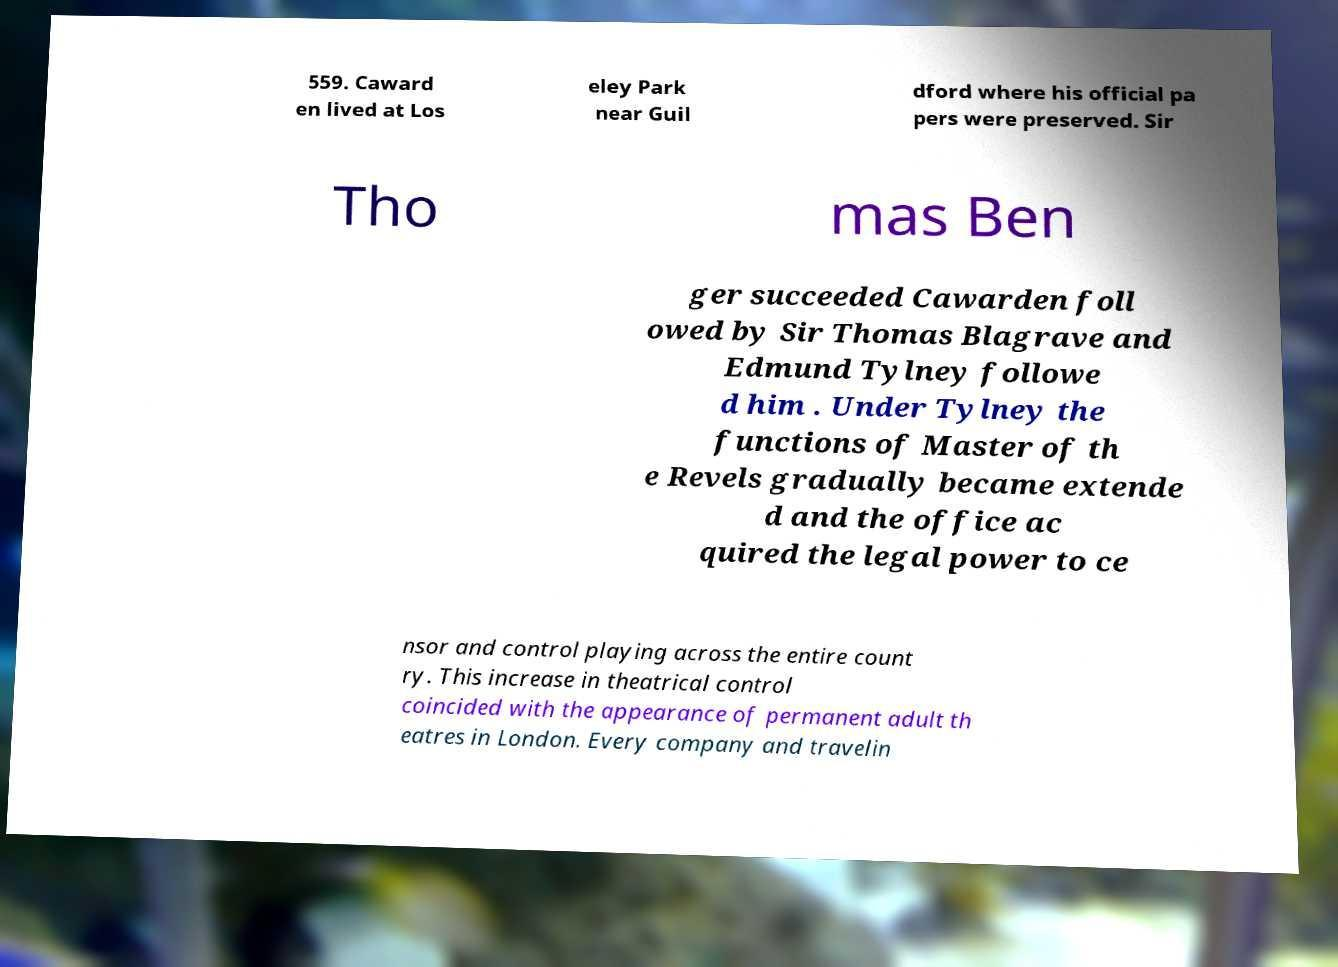What messages or text are displayed in this image? I need them in a readable, typed format. 559. Caward en lived at Los eley Park near Guil dford where his official pa pers were preserved. Sir Tho mas Ben ger succeeded Cawarden foll owed by Sir Thomas Blagrave and Edmund Tylney followe d him . Under Tylney the functions of Master of th e Revels gradually became extende d and the office ac quired the legal power to ce nsor and control playing across the entire count ry. This increase in theatrical control coincided with the appearance of permanent adult th eatres in London. Every company and travelin 